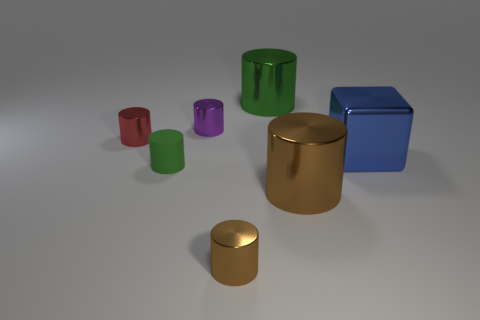Subtract 3 cylinders. How many cylinders are left? 3 Subtract all big cylinders. How many cylinders are left? 4 Subtract all brown cylinders. How many cylinders are left? 4 Subtract all gray cylinders. Subtract all gray spheres. How many cylinders are left? 6 Add 3 small purple things. How many objects exist? 10 Subtract all cylinders. How many objects are left? 1 Add 2 blocks. How many blocks are left? 3 Add 3 big purple rubber things. How many big purple rubber things exist? 3 Subtract 0 gray cubes. How many objects are left? 7 Subtract all brown metallic objects. Subtract all blue objects. How many objects are left? 4 